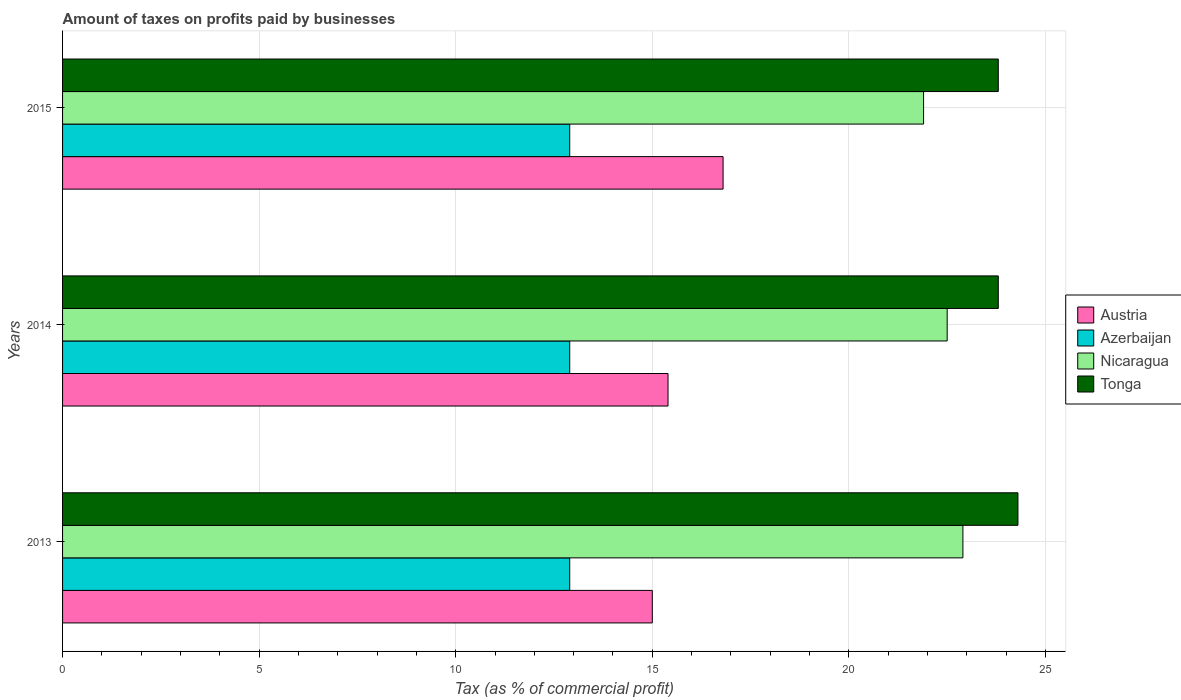How many different coloured bars are there?
Offer a very short reply. 4. How many bars are there on the 2nd tick from the top?
Provide a short and direct response. 4. How many bars are there on the 1st tick from the bottom?
Make the answer very short. 4. What is the label of the 2nd group of bars from the top?
Give a very brief answer. 2014. In how many cases, is the number of bars for a given year not equal to the number of legend labels?
Give a very brief answer. 0. What is the percentage of taxes paid by businesses in Nicaragua in 2013?
Make the answer very short. 22.9. Across all years, what is the maximum percentage of taxes paid by businesses in Nicaragua?
Make the answer very short. 22.9. Across all years, what is the minimum percentage of taxes paid by businesses in Austria?
Keep it short and to the point. 15. In which year was the percentage of taxes paid by businesses in Austria maximum?
Your answer should be compact. 2015. What is the total percentage of taxes paid by businesses in Tonga in the graph?
Provide a succinct answer. 71.9. What is the difference between the percentage of taxes paid by businesses in Nicaragua in 2013 and the percentage of taxes paid by businesses in Tonga in 2015?
Your answer should be compact. -0.9. In the year 2014, what is the difference between the percentage of taxes paid by businesses in Tonga and percentage of taxes paid by businesses in Austria?
Ensure brevity in your answer.  8.4. What is the ratio of the percentage of taxes paid by businesses in Austria in 2013 to that in 2014?
Provide a succinct answer. 0.97. Is the percentage of taxes paid by businesses in Tonga in 2014 less than that in 2015?
Your response must be concise. No. What is the difference between the highest and the second highest percentage of taxes paid by businesses in Nicaragua?
Make the answer very short. 0.4. What is the difference between the highest and the lowest percentage of taxes paid by businesses in Nicaragua?
Offer a terse response. 1. In how many years, is the percentage of taxes paid by businesses in Nicaragua greater than the average percentage of taxes paid by businesses in Nicaragua taken over all years?
Provide a succinct answer. 2. What does the 1st bar from the top in 2013 represents?
Your answer should be very brief. Tonga. Are all the bars in the graph horizontal?
Offer a very short reply. Yes. How many years are there in the graph?
Your answer should be compact. 3. Are the values on the major ticks of X-axis written in scientific E-notation?
Ensure brevity in your answer.  No. Does the graph contain grids?
Provide a succinct answer. Yes. Where does the legend appear in the graph?
Your answer should be compact. Center right. How many legend labels are there?
Provide a succinct answer. 4. What is the title of the graph?
Provide a succinct answer. Amount of taxes on profits paid by businesses. What is the label or title of the X-axis?
Make the answer very short. Tax (as % of commercial profit). What is the Tax (as % of commercial profit) of Austria in 2013?
Make the answer very short. 15. What is the Tax (as % of commercial profit) in Azerbaijan in 2013?
Your answer should be very brief. 12.9. What is the Tax (as % of commercial profit) in Nicaragua in 2013?
Your answer should be very brief. 22.9. What is the Tax (as % of commercial profit) of Tonga in 2013?
Make the answer very short. 24.3. What is the Tax (as % of commercial profit) in Tonga in 2014?
Give a very brief answer. 23.8. What is the Tax (as % of commercial profit) of Azerbaijan in 2015?
Give a very brief answer. 12.9. What is the Tax (as % of commercial profit) in Nicaragua in 2015?
Give a very brief answer. 21.9. What is the Tax (as % of commercial profit) of Tonga in 2015?
Ensure brevity in your answer.  23.8. Across all years, what is the maximum Tax (as % of commercial profit) of Austria?
Keep it short and to the point. 16.8. Across all years, what is the maximum Tax (as % of commercial profit) of Azerbaijan?
Make the answer very short. 12.9. Across all years, what is the maximum Tax (as % of commercial profit) of Nicaragua?
Provide a short and direct response. 22.9. Across all years, what is the maximum Tax (as % of commercial profit) of Tonga?
Keep it short and to the point. 24.3. Across all years, what is the minimum Tax (as % of commercial profit) in Azerbaijan?
Your answer should be compact. 12.9. Across all years, what is the minimum Tax (as % of commercial profit) in Nicaragua?
Provide a short and direct response. 21.9. Across all years, what is the minimum Tax (as % of commercial profit) in Tonga?
Provide a short and direct response. 23.8. What is the total Tax (as % of commercial profit) of Austria in the graph?
Make the answer very short. 47.2. What is the total Tax (as % of commercial profit) in Azerbaijan in the graph?
Your answer should be compact. 38.7. What is the total Tax (as % of commercial profit) in Nicaragua in the graph?
Make the answer very short. 67.3. What is the total Tax (as % of commercial profit) in Tonga in the graph?
Your answer should be very brief. 71.9. What is the difference between the Tax (as % of commercial profit) of Austria in 2013 and that in 2014?
Ensure brevity in your answer.  -0.4. What is the difference between the Tax (as % of commercial profit) of Azerbaijan in 2013 and that in 2014?
Provide a short and direct response. 0. What is the difference between the Tax (as % of commercial profit) in Nicaragua in 2013 and that in 2014?
Your response must be concise. 0.4. What is the difference between the Tax (as % of commercial profit) in Nicaragua in 2013 and that in 2015?
Your response must be concise. 1. What is the difference between the Tax (as % of commercial profit) in Tonga in 2013 and that in 2015?
Offer a very short reply. 0.5. What is the difference between the Tax (as % of commercial profit) of Austria in 2014 and that in 2015?
Your answer should be compact. -1.4. What is the difference between the Tax (as % of commercial profit) in Austria in 2013 and the Tax (as % of commercial profit) in Tonga in 2014?
Offer a very short reply. -8.8. What is the difference between the Tax (as % of commercial profit) in Nicaragua in 2013 and the Tax (as % of commercial profit) in Tonga in 2014?
Give a very brief answer. -0.9. What is the difference between the Tax (as % of commercial profit) of Nicaragua in 2013 and the Tax (as % of commercial profit) of Tonga in 2015?
Your answer should be very brief. -0.9. What is the difference between the Tax (as % of commercial profit) of Austria in 2014 and the Tax (as % of commercial profit) of Tonga in 2015?
Your response must be concise. -8.4. What is the difference between the Tax (as % of commercial profit) of Azerbaijan in 2014 and the Tax (as % of commercial profit) of Nicaragua in 2015?
Offer a very short reply. -9. What is the difference between the Tax (as % of commercial profit) of Nicaragua in 2014 and the Tax (as % of commercial profit) of Tonga in 2015?
Provide a short and direct response. -1.3. What is the average Tax (as % of commercial profit) in Austria per year?
Keep it short and to the point. 15.73. What is the average Tax (as % of commercial profit) in Nicaragua per year?
Make the answer very short. 22.43. What is the average Tax (as % of commercial profit) of Tonga per year?
Offer a terse response. 23.97. In the year 2013, what is the difference between the Tax (as % of commercial profit) in Austria and Tax (as % of commercial profit) in Tonga?
Offer a terse response. -9.3. In the year 2013, what is the difference between the Tax (as % of commercial profit) in Nicaragua and Tax (as % of commercial profit) in Tonga?
Your answer should be very brief. -1.4. In the year 2014, what is the difference between the Tax (as % of commercial profit) in Austria and Tax (as % of commercial profit) in Azerbaijan?
Give a very brief answer. 2.5. In the year 2014, what is the difference between the Tax (as % of commercial profit) in Austria and Tax (as % of commercial profit) in Nicaragua?
Offer a very short reply. -7.1. In the year 2014, what is the difference between the Tax (as % of commercial profit) of Austria and Tax (as % of commercial profit) of Tonga?
Ensure brevity in your answer.  -8.4. In the year 2014, what is the difference between the Tax (as % of commercial profit) of Nicaragua and Tax (as % of commercial profit) of Tonga?
Provide a succinct answer. -1.3. In the year 2015, what is the difference between the Tax (as % of commercial profit) in Austria and Tax (as % of commercial profit) in Nicaragua?
Offer a terse response. -5.1. In the year 2015, what is the difference between the Tax (as % of commercial profit) in Azerbaijan and Tax (as % of commercial profit) in Nicaragua?
Make the answer very short. -9. What is the ratio of the Tax (as % of commercial profit) in Nicaragua in 2013 to that in 2014?
Keep it short and to the point. 1.02. What is the ratio of the Tax (as % of commercial profit) in Tonga in 2013 to that in 2014?
Make the answer very short. 1.02. What is the ratio of the Tax (as % of commercial profit) in Austria in 2013 to that in 2015?
Ensure brevity in your answer.  0.89. What is the ratio of the Tax (as % of commercial profit) in Nicaragua in 2013 to that in 2015?
Ensure brevity in your answer.  1.05. What is the ratio of the Tax (as % of commercial profit) of Nicaragua in 2014 to that in 2015?
Offer a terse response. 1.03. What is the difference between the highest and the second highest Tax (as % of commercial profit) in Azerbaijan?
Offer a terse response. 0. What is the difference between the highest and the second highest Tax (as % of commercial profit) of Tonga?
Offer a terse response. 0.5. What is the difference between the highest and the lowest Tax (as % of commercial profit) in Austria?
Provide a short and direct response. 1.8. What is the difference between the highest and the lowest Tax (as % of commercial profit) of Azerbaijan?
Your response must be concise. 0. 